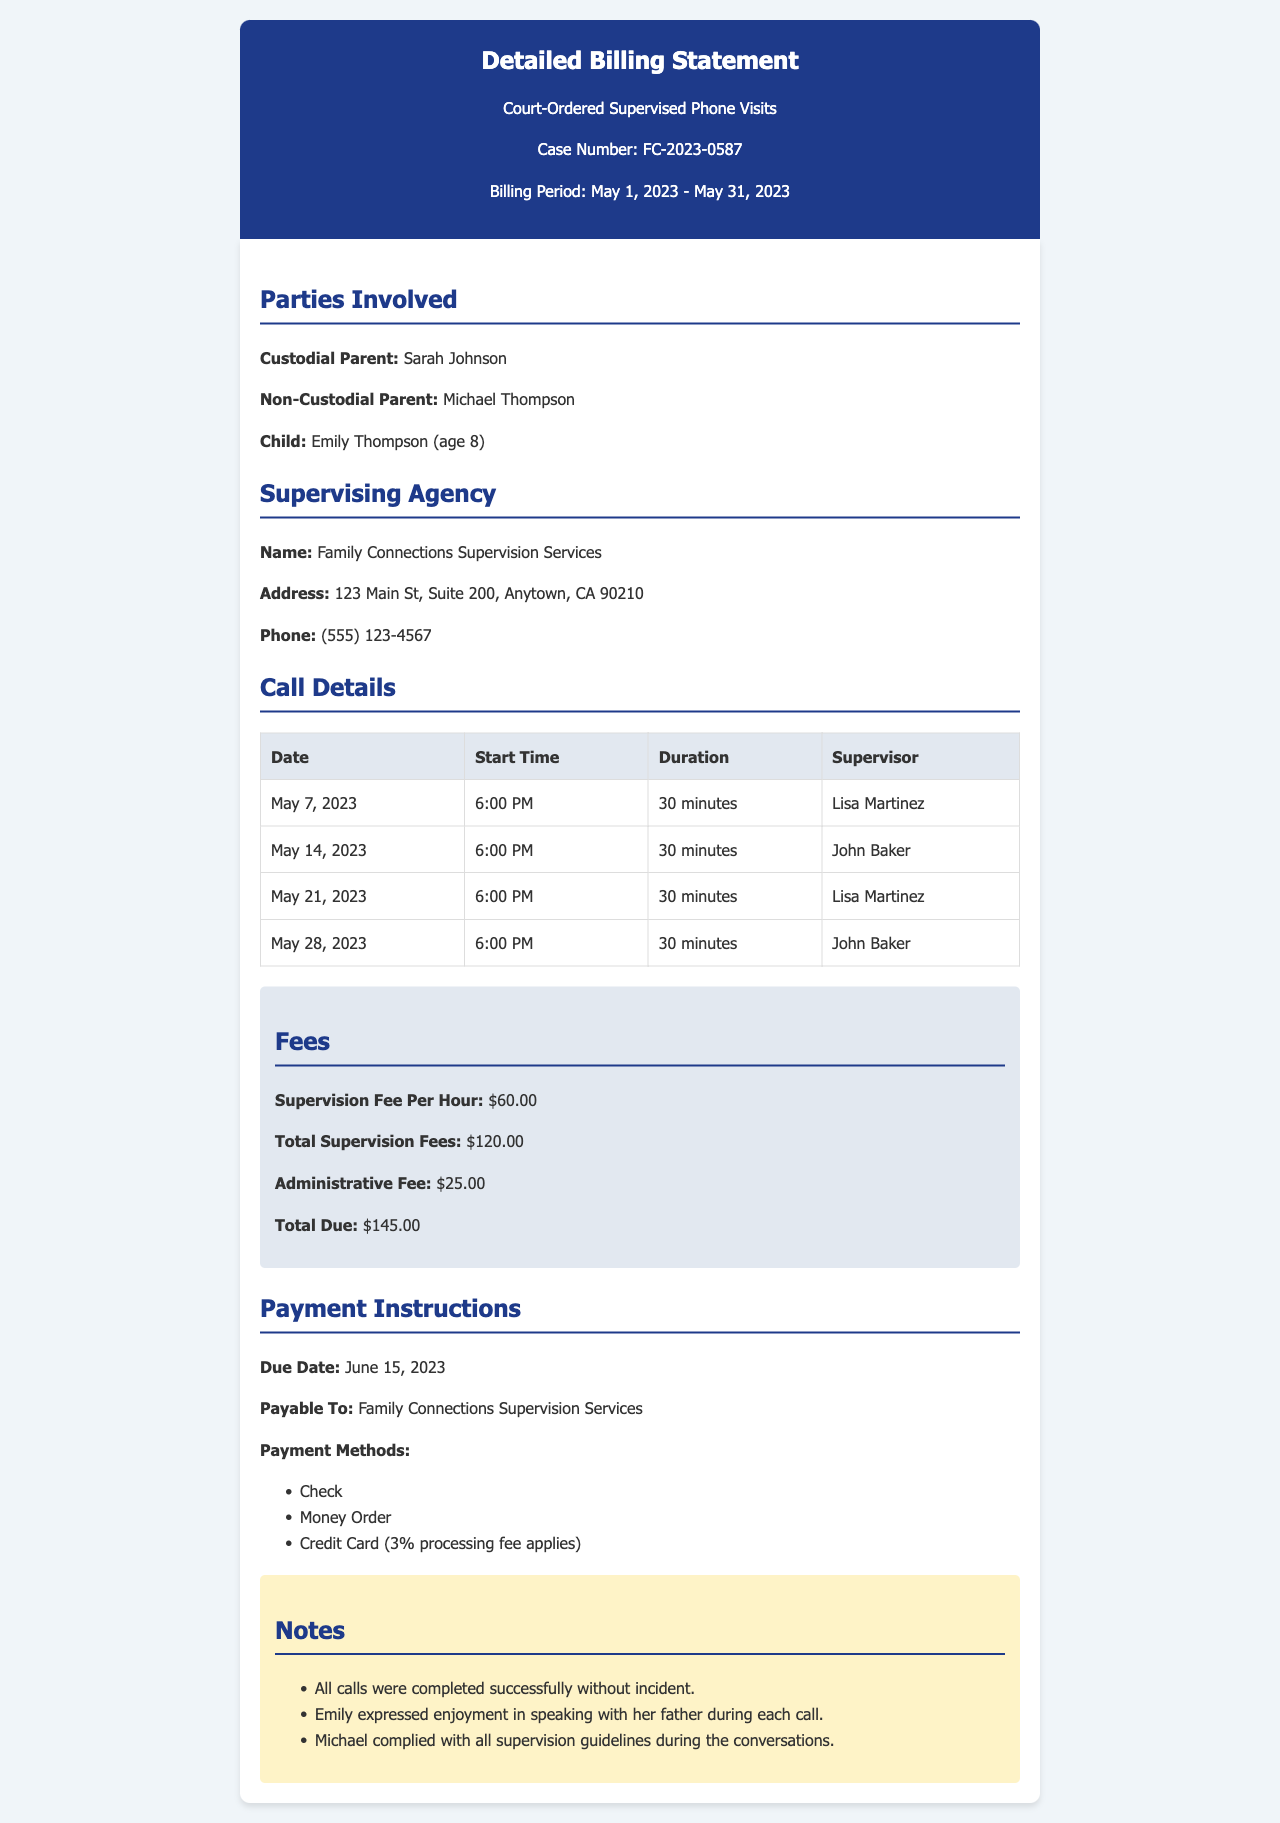what is the case number? The case number is listed in the heading of the document, which is FC-2023-0587.
Answer: FC-2023-0587 who is the custodial parent? The custodial parent is specified in the "Parties Involved" section as Sarah Johnson.
Answer: Sarah Johnson which agency supervised the phone visits? The supervising agency's name is mentioned as Family Connections Supervision Services in the document.
Answer: Family Connections Supervision Services what was the total supervision fee? The total supervision fees are stated in the "Fees" section, which totals $120.00 for the month.
Answer: $120.00 how many calls were made during the billing period? By counting the entries in the "Call Details" table, we can determine the number of calls made, which is four.
Answer: 4 who supervised the call on May 14, 2023? The name of the supervisor for the call on that date is found in the call details table, which is John Baker.
Answer: John Baker when is the payment due? The due date for payment is clearly indicated in the "Payment Instructions" section as June 15, 2023.
Answer: June 15, 2023 how long was each phone visit? The duration of each phone visit is listed consistently in the call details and is 30 minutes.
Answer: 30 minutes what is the administrative fee? The administrative fee is outlined in the "Fees" section as $25.00.
Answer: $25.00 